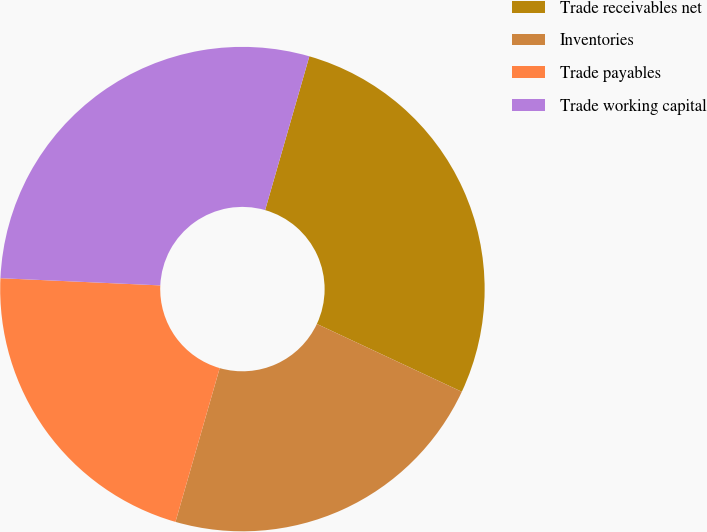Convert chart. <chart><loc_0><loc_0><loc_500><loc_500><pie_chart><fcel>Trade receivables net<fcel>Inventories<fcel>Trade payables<fcel>Trade working capital<nl><fcel>27.51%<fcel>22.49%<fcel>21.26%<fcel>28.74%<nl></chart> 